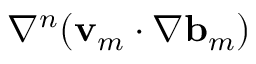<formula> <loc_0><loc_0><loc_500><loc_500>\nabla ^ { n } ( { v } _ { m } \cdot \nabla { b } _ { m } )</formula> 